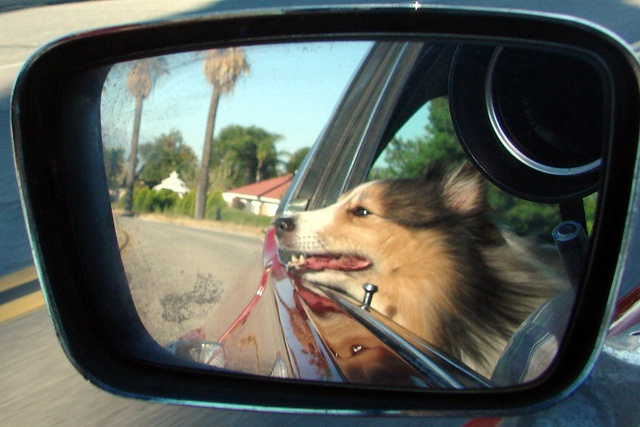Describe the objects in this image and their specific colors. I can see car in black, teal, gray, darkgray, and lightblue tones and dog in teal, black, tan, and gray tones in this image. 